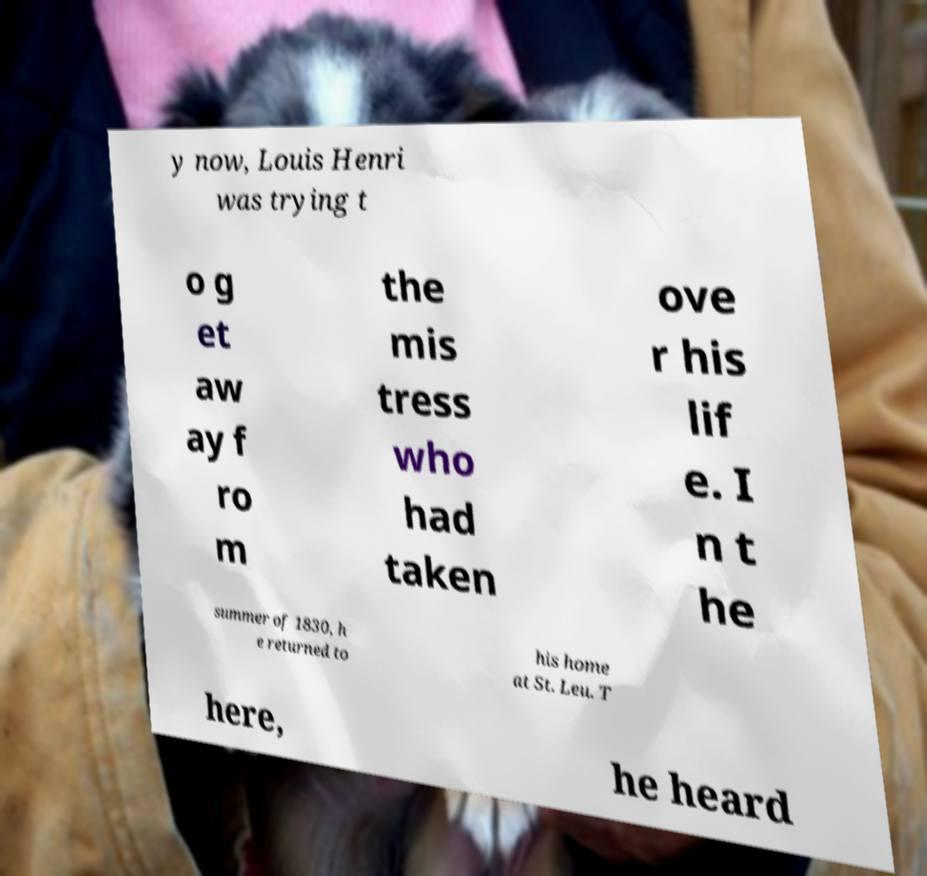Could you assist in decoding the text presented in this image and type it out clearly? y now, Louis Henri was trying t o g et aw ay f ro m the mis tress who had taken ove r his lif e. I n t he summer of 1830, h e returned to his home at St. Leu. T here, he heard 